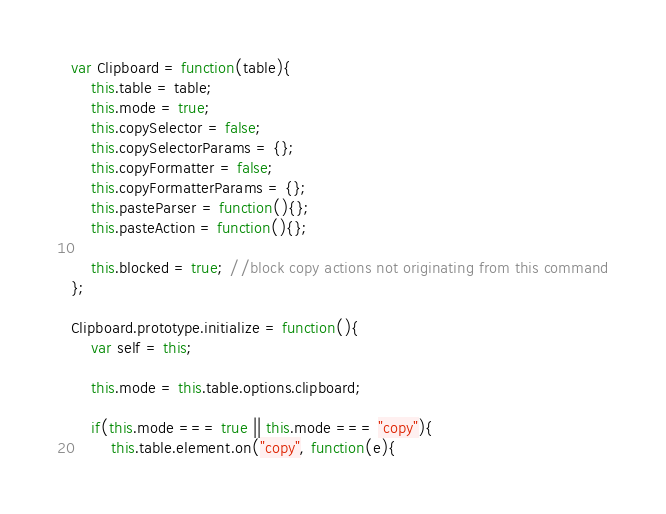<code> <loc_0><loc_0><loc_500><loc_500><_JavaScript_>var Clipboard = function(table){
	this.table = table;
	this.mode = true;
	this.copySelector = false;
	this.copySelectorParams = {};
	this.copyFormatter = false;
	this.copyFormatterParams = {};
	this.pasteParser = function(){};
	this.pasteAction = function(){};

	this.blocked = true; //block copy actions not originating from this command
};

Clipboard.prototype.initialize = function(){
	var self = this;

	this.mode = this.table.options.clipboard;

	if(this.mode === true || this.mode === "copy"){
		this.table.element.on("copy", function(e){</code> 